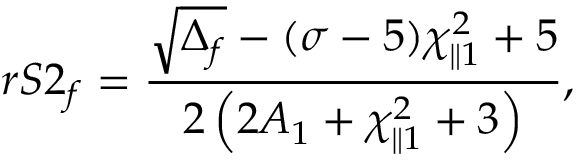<formula> <loc_0><loc_0><loc_500><loc_500>r S 2 _ { f } = \frac { \sqrt { \Delta _ { f } } - ( \sigma - 5 ) \chi _ { \| 1 } ^ { 2 } + 5 } { 2 \left ( 2 A _ { 1 } + \chi _ { \| 1 } ^ { 2 } + 3 \right ) } ,</formula> 